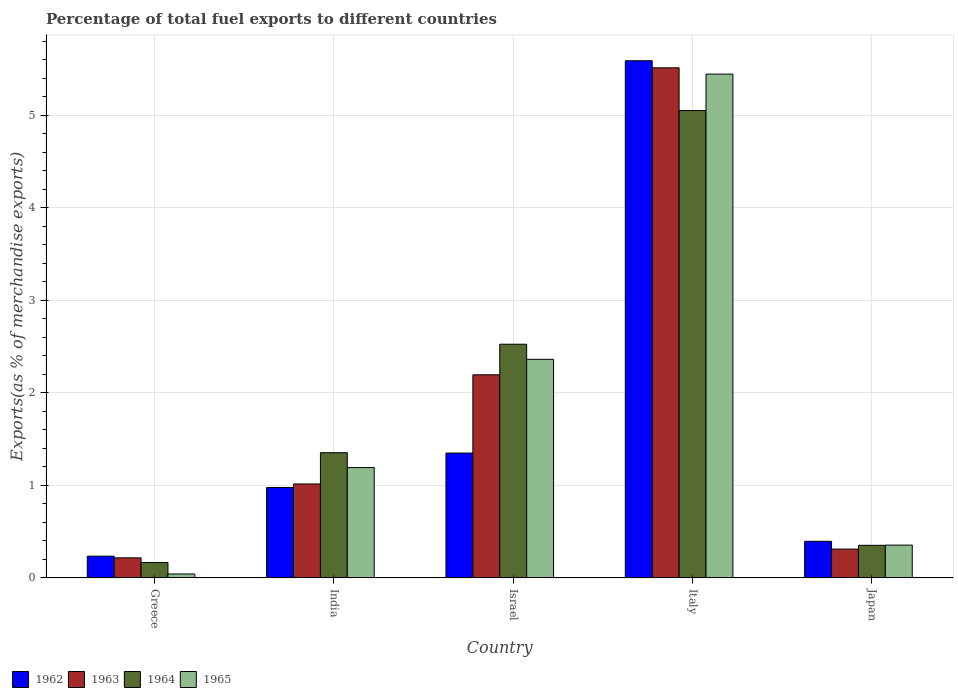How many different coloured bars are there?
Offer a very short reply. 4. How many groups of bars are there?
Give a very brief answer. 5. How many bars are there on the 4th tick from the left?
Offer a terse response. 4. How many bars are there on the 4th tick from the right?
Provide a succinct answer. 4. In how many cases, is the number of bars for a given country not equal to the number of legend labels?
Make the answer very short. 0. What is the percentage of exports to different countries in 1964 in India?
Your response must be concise. 1.35. Across all countries, what is the maximum percentage of exports to different countries in 1962?
Your response must be concise. 5.59. Across all countries, what is the minimum percentage of exports to different countries in 1964?
Provide a succinct answer. 0.17. In which country was the percentage of exports to different countries in 1963 minimum?
Offer a very short reply. Greece. What is the total percentage of exports to different countries in 1964 in the graph?
Provide a succinct answer. 9.45. What is the difference between the percentage of exports to different countries in 1962 in India and that in Israel?
Your answer should be very brief. -0.37. What is the difference between the percentage of exports to different countries in 1962 in Greece and the percentage of exports to different countries in 1964 in Italy?
Provide a succinct answer. -4.82. What is the average percentage of exports to different countries in 1963 per country?
Keep it short and to the point. 1.85. What is the difference between the percentage of exports to different countries of/in 1962 and percentage of exports to different countries of/in 1965 in India?
Offer a terse response. -0.22. In how many countries, is the percentage of exports to different countries in 1964 greater than 0.2 %?
Offer a terse response. 4. What is the ratio of the percentage of exports to different countries in 1962 in Greece to that in Italy?
Your answer should be very brief. 0.04. Is the percentage of exports to different countries in 1963 in India less than that in Japan?
Provide a short and direct response. No. Is the difference between the percentage of exports to different countries in 1962 in Greece and India greater than the difference between the percentage of exports to different countries in 1965 in Greece and India?
Provide a short and direct response. Yes. What is the difference between the highest and the second highest percentage of exports to different countries in 1962?
Offer a very short reply. -0.37. What is the difference between the highest and the lowest percentage of exports to different countries in 1964?
Give a very brief answer. 4.88. Is it the case that in every country, the sum of the percentage of exports to different countries in 1963 and percentage of exports to different countries in 1962 is greater than the sum of percentage of exports to different countries in 1964 and percentage of exports to different countries in 1965?
Ensure brevity in your answer.  No. What does the 4th bar from the left in Greece represents?
Offer a terse response. 1965. How many bars are there?
Provide a succinct answer. 20. Are the values on the major ticks of Y-axis written in scientific E-notation?
Provide a short and direct response. No. Does the graph contain any zero values?
Ensure brevity in your answer.  No. How many legend labels are there?
Your answer should be very brief. 4. What is the title of the graph?
Give a very brief answer. Percentage of total fuel exports to different countries. Does "1973" appear as one of the legend labels in the graph?
Offer a very short reply. No. What is the label or title of the Y-axis?
Provide a short and direct response. Exports(as % of merchandise exports). What is the Exports(as % of merchandise exports) of 1962 in Greece?
Your response must be concise. 0.24. What is the Exports(as % of merchandise exports) of 1963 in Greece?
Offer a terse response. 0.22. What is the Exports(as % of merchandise exports) of 1964 in Greece?
Provide a succinct answer. 0.17. What is the Exports(as % of merchandise exports) of 1965 in Greece?
Provide a succinct answer. 0.04. What is the Exports(as % of merchandise exports) in 1962 in India?
Ensure brevity in your answer.  0.98. What is the Exports(as % of merchandise exports) of 1963 in India?
Give a very brief answer. 1.02. What is the Exports(as % of merchandise exports) in 1964 in India?
Your answer should be compact. 1.35. What is the Exports(as % of merchandise exports) of 1965 in India?
Your answer should be very brief. 1.19. What is the Exports(as % of merchandise exports) of 1962 in Israel?
Keep it short and to the point. 1.35. What is the Exports(as % of merchandise exports) in 1963 in Israel?
Your response must be concise. 2.2. What is the Exports(as % of merchandise exports) of 1964 in Israel?
Make the answer very short. 2.53. What is the Exports(as % of merchandise exports) of 1965 in Israel?
Your answer should be compact. 2.36. What is the Exports(as % of merchandise exports) of 1962 in Italy?
Provide a succinct answer. 5.59. What is the Exports(as % of merchandise exports) of 1963 in Italy?
Your response must be concise. 5.51. What is the Exports(as % of merchandise exports) of 1964 in Italy?
Give a very brief answer. 5.05. What is the Exports(as % of merchandise exports) of 1965 in Italy?
Make the answer very short. 5.45. What is the Exports(as % of merchandise exports) in 1962 in Japan?
Your answer should be compact. 0.4. What is the Exports(as % of merchandise exports) in 1963 in Japan?
Keep it short and to the point. 0.31. What is the Exports(as % of merchandise exports) in 1964 in Japan?
Your response must be concise. 0.35. What is the Exports(as % of merchandise exports) of 1965 in Japan?
Make the answer very short. 0.36. Across all countries, what is the maximum Exports(as % of merchandise exports) of 1962?
Offer a very short reply. 5.59. Across all countries, what is the maximum Exports(as % of merchandise exports) of 1963?
Your response must be concise. 5.51. Across all countries, what is the maximum Exports(as % of merchandise exports) of 1964?
Your answer should be compact. 5.05. Across all countries, what is the maximum Exports(as % of merchandise exports) of 1965?
Offer a very short reply. 5.45. Across all countries, what is the minimum Exports(as % of merchandise exports) in 1962?
Provide a short and direct response. 0.24. Across all countries, what is the minimum Exports(as % of merchandise exports) in 1963?
Make the answer very short. 0.22. Across all countries, what is the minimum Exports(as % of merchandise exports) in 1964?
Ensure brevity in your answer.  0.17. Across all countries, what is the minimum Exports(as % of merchandise exports) in 1965?
Your response must be concise. 0.04. What is the total Exports(as % of merchandise exports) in 1962 in the graph?
Your answer should be compact. 8.55. What is the total Exports(as % of merchandise exports) in 1963 in the graph?
Offer a very short reply. 9.26. What is the total Exports(as % of merchandise exports) of 1964 in the graph?
Your response must be concise. 9.45. What is the total Exports(as % of merchandise exports) in 1965 in the graph?
Keep it short and to the point. 9.4. What is the difference between the Exports(as % of merchandise exports) in 1962 in Greece and that in India?
Make the answer very short. -0.74. What is the difference between the Exports(as % of merchandise exports) in 1963 in Greece and that in India?
Keep it short and to the point. -0.8. What is the difference between the Exports(as % of merchandise exports) in 1964 in Greece and that in India?
Provide a succinct answer. -1.19. What is the difference between the Exports(as % of merchandise exports) in 1965 in Greece and that in India?
Give a very brief answer. -1.15. What is the difference between the Exports(as % of merchandise exports) of 1962 in Greece and that in Israel?
Your answer should be compact. -1.11. What is the difference between the Exports(as % of merchandise exports) of 1963 in Greece and that in Israel?
Offer a very short reply. -1.98. What is the difference between the Exports(as % of merchandise exports) of 1964 in Greece and that in Israel?
Your response must be concise. -2.36. What is the difference between the Exports(as % of merchandise exports) in 1965 in Greece and that in Israel?
Ensure brevity in your answer.  -2.32. What is the difference between the Exports(as % of merchandise exports) of 1962 in Greece and that in Italy?
Offer a terse response. -5.35. What is the difference between the Exports(as % of merchandise exports) in 1963 in Greece and that in Italy?
Your answer should be very brief. -5.3. What is the difference between the Exports(as % of merchandise exports) of 1964 in Greece and that in Italy?
Your answer should be very brief. -4.88. What is the difference between the Exports(as % of merchandise exports) in 1965 in Greece and that in Italy?
Your response must be concise. -5.4. What is the difference between the Exports(as % of merchandise exports) in 1962 in Greece and that in Japan?
Offer a very short reply. -0.16. What is the difference between the Exports(as % of merchandise exports) in 1963 in Greece and that in Japan?
Ensure brevity in your answer.  -0.09. What is the difference between the Exports(as % of merchandise exports) in 1964 in Greece and that in Japan?
Ensure brevity in your answer.  -0.19. What is the difference between the Exports(as % of merchandise exports) in 1965 in Greece and that in Japan?
Your response must be concise. -0.31. What is the difference between the Exports(as % of merchandise exports) in 1962 in India and that in Israel?
Give a very brief answer. -0.37. What is the difference between the Exports(as % of merchandise exports) of 1963 in India and that in Israel?
Provide a succinct answer. -1.18. What is the difference between the Exports(as % of merchandise exports) of 1964 in India and that in Israel?
Your answer should be very brief. -1.17. What is the difference between the Exports(as % of merchandise exports) in 1965 in India and that in Israel?
Your answer should be compact. -1.17. What is the difference between the Exports(as % of merchandise exports) in 1962 in India and that in Italy?
Your answer should be very brief. -4.61. What is the difference between the Exports(as % of merchandise exports) in 1963 in India and that in Italy?
Give a very brief answer. -4.5. What is the difference between the Exports(as % of merchandise exports) in 1964 in India and that in Italy?
Your answer should be compact. -3.7. What is the difference between the Exports(as % of merchandise exports) of 1965 in India and that in Italy?
Your answer should be compact. -4.25. What is the difference between the Exports(as % of merchandise exports) in 1962 in India and that in Japan?
Offer a very short reply. 0.58. What is the difference between the Exports(as % of merchandise exports) of 1963 in India and that in Japan?
Ensure brevity in your answer.  0.7. What is the difference between the Exports(as % of merchandise exports) in 1964 in India and that in Japan?
Your answer should be compact. 1. What is the difference between the Exports(as % of merchandise exports) in 1965 in India and that in Japan?
Make the answer very short. 0.84. What is the difference between the Exports(as % of merchandise exports) in 1962 in Israel and that in Italy?
Give a very brief answer. -4.24. What is the difference between the Exports(as % of merchandise exports) of 1963 in Israel and that in Italy?
Offer a very short reply. -3.32. What is the difference between the Exports(as % of merchandise exports) of 1964 in Israel and that in Italy?
Offer a very short reply. -2.53. What is the difference between the Exports(as % of merchandise exports) in 1965 in Israel and that in Italy?
Give a very brief answer. -3.08. What is the difference between the Exports(as % of merchandise exports) in 1962 in Israel and that in Japan?
Provide a short and direct response. 0.95. What is the difference between the Exports(as % of merchandise exports) in 1963 in Israel and that in Japan?
Your answer should be compact. 1.88. What is the difference between the Exports(as % of merchandise exports) in 1964 in Israel and that in Japan?
Your answer should be very brief. 2.17. What is the difference between the Exports(as % of merchandise exports) in 1965 in Israel and that in Japan?
Offer a terse response. 2.01. What is the difference between the Exports(as % of merchandise exports) of 1962 in Italy and that in Japan?
Provide a succinct answer. 5.19. What is the difference between the Exports(as % of merchandise exports) in 1963 in Italy and that in Japan?
Offer a terse response. 5.2. What is the difference between the Exports(as % of merchandise exports) of 1964 in Italy and that in Japan?
Your answer should be very brief. 4.7. What is the difference between the Exports(as % of merchandise exports) of 1965 in Italy and that in Japan?
Ensure brevity in your answer.  5.09. What is the difference between the Exports(as % of merchandise exports) of 1962 in Greece and the Exports(as % of merchandise exports) of 1963 in India?
Your answer should be compact. -0.78. What is the difference between the Exports(as % of merchandise exports) in 1962 in Greece and the Exports(as % of merchandise exports) in 1964 in India?
Provide a short and direct response. -1.12. What is the difference between the Exports(as % of merchandise exports) in 1962 in Greece and the Exports(as % of merchandise exports) in 1965 in India?
Give a very brief answer. -0.96. What is the difference between the Exports(as % of merchandise exports) of 1963 in Greece and the Exports(as % of merchandise exports) of 1964 in India?
Offer a very short reply. -1.14. What is the difference between the Exports(as % of merchandise exports) of 1963 in Greece and the Exports(as % of merchandise exports) of 1965 in India?
Your answer should be compact. -0.98. What is the difference between the Exports(as % of merchandise exports) in 1964 in Greece and the Exports(as % of merchandise exports) in 1965 in India?
Your response must be concise. -1.03. What is the difference between the Exports(as % of merchandise exports) of 1962 in Greece and the Exports(as % of merchandise exports) of 1963 in Israel?
Offer a very short reply. -1.96. What is the difference between the Exports(as % of merchandise exports) in 1962 in Greece and the Exports(as % of merchandise exports) in 1964 in Israel?
Give a very brief answer. -2.29. What is the difference between the Exports(as % of merchandise exports) in 1962 in Greece and the Exports(as % of merchandise exports) in 1965 in Israel?
Provide a short and direct response. -2.13. What is the difference between the Exports(as % of merchandise exports) of 1963 in Greece and the Exports(as % of merchandise exports) of 1964 in Israel?
Your answer should be very brief. -2.31. What is the difference between the Exports(as % of merchandise exports) in 1963 in Greece and the Exports(as % of merchandise exports) in 1965 in Israel?
Your response must be concise. -2.15. What is the difference between the Exports(as % of merchandise exports) of 1964 in Greece and the Exports(as % of merchandise exports) of 1965 in Israel?
Ensure brevity in your answer.  -2.2. What is the difference between the Exports(as % of merchandise exports) in 1962 in Greece and the Exports(as % of merchandise exports) in 1963 in Italy?
Offer a terse response. -5.28. What is the difference between the Exports(as % of merchandise exports) in 1962 in Greece and the Exports(as % of merchandise exports) in 1964 in Italy?
Make the answer very short. -4.82. What is the difference between the Exports(as % of merchandise exports) in 1962 in Greece and the Exports(as % of merchandise exports) in 1965 in Italy?
Offer a terse response. -5.21. What is the difference between the Exports(as % of merchandise exports) in 1963 in Greece and the Exports(as % of merchandise exports) in 1964 in Italy?
Ensure brevity in your answer.  -4.83. What is the difference between the Exports(as % of merchandise exports) in 1963 in Greece and the Exports(as % of merchandise exports) in 1965 in Italy?
Keep it short and to the point. -5.23. What is the difference between the Exports(as % of merchandise exports) of 1964 in Greece and the Exports(as % of merchandise exports) of 1965 in Italy?
Provide a succinct answer. -5.28. What is the difference between the Exports(as % of merchandise exports) in 1962 in Greece and the Exports(as % of merchandise exports) in 1963 in Japan?
Give a very brief answer. -0.08. What is the difference between the Exports(as % of merchandise exports) of 1962 in Greece and the Exports(as % of merchandise exports) of 1964 in Japan?
Ensure brevity in your answer.  -0.12. What is the difference between the Exports(as % of merchandise exports) in 1962 in Greece and the Exports(as % of merchandise exports) in 1965 in Japan?
Offer a terse response. -0.12. What is the difference between the Exports(as % of merchandise exports) in 1963 in Greece and the Exports(as % of merchandise exports) in 1964 in Japan?
Ensure brevity in your answer.  -0.14. What is the difference between the Exports(as % of merchandise exports) in 1963 in Greece and the Exports(as % of merchandise exports) in 1965 in Japan?
Make the answer very short. -0.14. What is the difference between the Exports(as % of merchandise exports) of 1964 in Greece and the Exports(as % of merchandise exports) of 1965 in Japan?
Ensure brevity in your answer.  -0.19. What is the difference between the Exports(as % of merchandise exports) in 1962 in India and the Exports(as % of merchandise exports) in 1963 in Israel?
Your response must be concise. -1.22. What is the difference between the Exports(as % of merchandise exports) in 1962 in India and the Exports(as % of merchandise exports) in 1964 in Israel?
Offer a terse response. -1.55. What is the difference between the Exports(as % of merchandise exports) in 1962 in India and the Exports(as % of merchandise exports) in 1965 in Israel?
Offer a terse response. -1.38. What is the difference between the Exports(as % of merchandise exports) of 1963 in India and the Exports(as % of merchandise exports) of 1964 in Israel?
Keep it short and to the point. -1.51. What is the difference between the Exports(as % of merchandise exports) in 1963 in India and the Exports(as % of merchandise exports) in 1965 in Israel?
Your response must be concise. -1.35. What is the difference between the Exports(as % of merchandise exports) in 1964 in India and the Exports(as % of merchandise exports) in 1965 in Israel?
Your response must be concise. -1.01. What is the difference between the Exports(as % of merchandise exports) of 1962 in India and the Exports(as % of merchandise exports) of 1963 in Italy?
Give a very brief answer. -4.54. What is the difference between the Exports(as % of merchandise exports) in 1962 in India and the Exports(as % of merchandise exports) in 1964 in Italy?
Offer a terse response. -4.07. What is the difference between the Exports(as % of merchandise exports) in 1962 in India and the Exports(as % of merchandise exports) in 1965 in Italy?
Provide a succinct answer. -4.47. What is the difference between the Exports(as % of merchandise exports) in 1963 in India and the Exports(as % of merchandise exports) in 1964 in Italy?
Provide a short and direct response. -4.04. What is the difference between the Exports(as % of merchandise exports) of 1963 in India and the Exports(as % of merchandise exports) of 1965 in Italy?
Your answer should be compact. -4.43. What is the difference between the Exports(as % of merchandise exports) of 1964 in India and the Exports(as % of merchandise exports) of 1965 in Italy?
Offer a very short reply. -4.09. What is the difference between the Exports(as % of merchandise exports) of 1962 in India and the Exports(as % of merchandise exports) of 1963 in Japan?
Your answer should be very brief. 0.67. What is the difference between the Exports(as % of merchandise exports) in 1962 in India and the Exports(as % of merchandise exports) in 1964 in Japan?
Offer a terse response. 0.63. What is the difference between the Exports(as % of merchandise exports) of 1962 in India and the Exports(as % of merchandise exports) of 1965 in Japan?
Offer a terse response. 0.62. What is the difference between the Exports(as % of merchandise exports) in 1963 in India and the Exports(as % of merchandise exports) in 1964 in Japan?
Make the answer very short. 0.66. What is the difference between the Exports(as % of merchandise exports) in 1963 in India and the Exports(as % of merchandise exports) in 1965 in Japan?
Keep it short and to the point. 0.66. What is the difference between the Exports(as % of merchandise exports) in 1962 in Israel and the Exports(as % of merchandise exports) in 1963 in Italy?
Give a very brief answer. -4.16. What is the difference between the Exports(as % of merchandise exports) in 1962 in Israel and the Exports(as % of merchandise exports) in 1964 in Italy?
Keep it short and to the point. -3.7. What is the difference between the Exports(as % of merchandise exports) in 1962 in Israel and the Exports(as % of merchandise exports) in 1965 in Italy?
Your response must be concise. -4.09. What is the difference between the Exports(as % of merchandise exports) of 1963 in Israel and the Exports(as % of merchandise exports) of 1964 in Italy?
Keep it short and to the point. -2.86. What is the difference between the Exports(as % of merchandise exports) in 1963 in Israel and the Exports(as % of merchandise exports) in 1965 in Italy?
Your answer should be very brief. -3.25. What is the difference between the Exports(as % of merchandise exports) of 1964 in Israel and the Exports(as % of merchandise exports) of 1965 in Italy?
Your answer should be very brief. -2.92. What is the difference between the Exports(as % of merchandise exports) in 1962 in Israel and the Exports(as % of merchandise exports) in 1963 in Japan?
Offer a very short reply. 1.04. What is the difference between the Exports(as % of merchandise exports) of 1962 in Israel and the Exports(as % of merchandise exports) of 1964 in Japan?
Your answer should be very brief. 1. What is the difference between the Exports(as % of merchandise exports) in 1963 in Israel and the Exports(as % of merchandise exports) in 1964 in Japan?
Give a very brief answer. 1.84. What is the difference between the Exports(as % of merchandise exports) of 1963 in Israel and the Exports(as % of merchandise exports) of 1965 in Japan?
Ensure brevity in your answer.  1.84. What is the difference between the Exports(as % of merchandise exports) in 1964 in Israel and the Exports(as % of merchandise exports) in 1965 in Japan?
Ensure brevity in your answer.  2.17. What is the difference between the Exports(as % of merchandise exports) of 1962 in Italy and the Exports(as % of merchandise exports) of 1963 in Japan?
Your response must be concise. 5.28. What is the difference between the Exports(as % of merchandise exports) of 1962 in Italy and the Exports(as % of merchandise exports) of 1964 in Japan?
Provide a short and direct response. 5.24. What is the difference between the Exports(as % of merchandise exports) of 1962 in Italy and the Exports(as % of merchandise exports) of 1965 in Japan?
Offer a very short reply. 5.23. What is the difference between the Exports(as % of merchandise exports) of 1963 in Italy and the Exports(as % of merchandise exports) of 1964 in Japan?
Your answer should be compact. 5.16. What is the difference between the Exports(as % of merchandise exports) of 1963 in Italy and the Exports(as % of merchandise exports) of 1965 in Japan?
Make the answer very short. 5.16. What is the difference between the Exports(as % of merchandise exports) in 1964 in Italy and the Exports(as % of merchandise exports) in 1965 in Japan?
Offer a terse response. 4.7. What is the average Exports(as % of merchandise exports) in 1962 per country?
Your answer should be compact. 1.71. What is the average Exports(as % of merchandise exports) in 1963 per country?
Give a very brief answer. 1.85. What is the average Exports(as % of merchandise exports) of 1964 per country?
Your answer should be very brief. 1.89. What is the average Exports(as % of merchandise exports) of 1965 per country?
Offer a very short reply. 1.88. What is the difference between the Exports(as % of merchandise exports) in 1962 and Exports(as % of merchandise exports) in 1963 in Greece?
Offer a terse response. 0.02. What is the difference between the Exports(as % of merchandise exports) of 1962 and Exports(as % of merchandise exports) of 1964 in Greece?
Give a very brief answer. 0.07. What is the difference between the Exports(as % of merchandise exports) of 1962 and Exports(as % of merchandise exports) of 1965 in Greece?
Make the answer very short. 0.19. What is the difference between the Exports(as % of merchandise exports) in 1963 and Exports(as % of merchandise exports) in 1964 in Greece?
Give a very brief answer. 0.05. What is the difference between the Exports(as % of merchandise exports) in 1963 and Exports(as % of merchandise exports) in 1965 in Greece?
Your answer should be very brief. 0.17. What is the difference between the Exports(as % of merchandise exports) in 1964 and Exports(as % of merchandise exports) in 1965 in Greece?
Offer a very short reply. 0.12. What is the difference between the Exports(as % of merchandise exports) of 1962 and Exports(as % of merchandise exports) of 1963 in India?
Your answer should be very brief. -0.04. What is the difference between the Exports(as % of merchandise exports) in 1962 and Exports(as % of merchandise exports) in 1964 in India?
Your answer should be compact. -0.38. What is the difference between the Exports(as % of merchandise exports) in 1962 and Exports(as % of merchandise exports) in 1965 in India?
Your answer should be compact. -0.22. What is the difference between the Exports(as % of merchandise exports) of 1963 and Exports(as % of merchandise exports) of 1964 in India?
Give a very brief answer. -0.34. What is the difference between the Exports(as % of merchandise exports) in 1963 and Exports(as % of merchandise exports) in 1965 in India?
Give a very brief answer. -0.18. What is the difference between the Exports(as % of merchandise exports) in 1964 and Exports(as % of merchandise exports) in 1965 in India?
Provide a succinct answer. 0.16. What is the difference between the Exports(as % of merchandise exports) of 1962 and Exports(as % of merchandise exports) of 1963 in Israel?
Provide a short and direct response. -0.85. What is the difference between the Exports(as % of merchandise exports) in 1962 and Exports(as % of merchandise exports) in 1964 in Israel?
Your answer should be compact. -1.18. What is the difference between the Exports(as % of merchandise exports) in 1962 and Exports(as % of merchandise exports) in 1965 in Israel?
Give a very brief answer. -1.01. What is the difference between the Exports(as % of merchandise exports) in 1963 and Exports(as % of merchandise exports) in 1964 in Israel?
Offer a very short reply. -0.33. What is the difference between the Exports(as % of merchandise exports) in 1963 and Exports(as % of merchandise exports) in 1965 in Israel?
Give a very brief answer. -0.17. What is the difference between the Exports(as % of merchandise exports) of 1964 and Exports(as % of merchandise exports) of 1965 in Israel?
Offer a very short reply. 0.16. What is the difference between the Exports(as % of merchandise exports) of 1962 and Exports(as % of merchandise exports) of 1963 in Italy?
Your answer should be very brief. 0.08. What is the difference between the Exports(as % of merchandise exports) of 1962 and Exports(as % of merchandise exports) of 1964 in Italy?
Your answer should be compact. 0.54. What is the difference between the Exports(as % of merchandise exports) in 1962 and Exports(as % of merchandise exports) in 1965 in Italy?
Make the answer very short. 0.14. What is the difference between the Exports(as % of merchandise exports) in 1963 and Exports(as % of merchandise exports) in 1964 in Italy?
Offer a terse response. 0.46. What is the difference between the Exports(as % of merchandise exports) in 1963 and Exports(as % of merchandise exports) in 1965 in Italy?
Give a very brief answer. 0.07. What is the difference between the Exports(as % of merchandise exports) of 1964 and Exports(as % of merchandise exports) of 1965 in Italy?
Offer a terse response. -0.39. What is the difference between the Exports(as % of merchandise exports) of 1962 and Exports(as % of merchandise exports) of 1963 in Japan?
Ensure brevity in your answer.  0.08. What is the difference between the Exports(as % of merchandise exports) of 1962 and Exports(as % of merchandise exports) of 1964 in Japan?
Provide a succinct answer. 0.04. What is the difference between the Exports(as % of merchandise exports) of 1962 and Exports(as % of merchandise exports) of 1965 in Japan?
Give a very brief answer. 0.04. What is the difference between the Exports(as % of merchandise exports) of 1963 and Exports(as % of merchandise exports) of 1964 in Japan?
Your response must be concise. -0.04. What is the difference between the Exports(as % of merchandise exports) in 1963 and Exports(as % of merchandise exports) in 1965 in Japan?
Give a very brief answer. -0.04. What is the difference between the Exports(as % of merchandise exports) in 1964 and Exports(as % of merchandise exports) in 1965 in Japan?
Your response must be concise. -0. What is the ratio of the Exports(as % of merchandise exports) of 1962 in Greece to that in India?
Keep it short and to the point. 0.24. What is the ratio of the Exports(as % of merchandise exports) of 1963 in Greece to that in India?
Give a very brief answer. 0.21. What is the ratio of the Exports(as % of merchandise exports) in 1964 in Greece to that in India?
Make the answer very short. 0.12. What is the ratio of the Exports(as % of merchandise exports) in 1965 in Greece to that in India?
Provide a succinct answer. 0.04. What is the ratio of the Exports(as % of merchandise exports) in 1962 in Greece to that in Israel?
Give a very brief answer. 0.17. What is the ratio of the Exports(as % of merchandise exports) in 1963 in Greece to that in Israel?
Offer a very short reply. 0.1. What is the ratio of the Exports(as % of merchandise exports) in 1964 in Greece to that in Israel?
Keep it short and to the point. 0.07. What is the ratio of the Exports(as % of merchandise exports) of 1965 in Greece to that in Israel?
Your answer should be compact. 0.02. What is the ratio of the Exports(as % of merchandise exports) in 1962 in Greece to that in Italy?
Your answer should be very brief. 0.04. What is the ratio of the Exports(as % of merchandise exports) of 1963 in Greece to that in Italy?
Give a very brief answer. 0.04. What is the ratio of the Exports(as % of merchandise exports) in 1964 in Greece to that in Italy?
Ensure brevity in your answer.  0.03. What is the ratio of the Exports(as % of merchandise exports) in 1965 in Greece to that in Italy?
Provide a short and direct response. 0.01. What is the ratio of the Exports(as % of merchandise exports) in 1962 in Greece to that in Japan?
Keep it short and to the point. 0.59. What is the ratio of the Exports(as % of merchandise exports) in 1963 in Greece to that in Japan?
Offer a very short reply. 0.7. What is the ratio of the Exports(as % of merchandise exports) of 1964 in Greece to that in Japan?
Provide a succinct answer. 0.47. What is the ratio of the Exports(as % of merchandise exports) in 1965 in Greece to that in Japan?
Provide a succinct answer. 0.12. What is the ratio of the Exports(as % of merchandise exports) of 1962 in India to that in Israel?
Your answer should be very brief. 0.72. What is the ratio of the Exports(as % of merchandise exports) in 1963 in India to that in Israel?
Provide a succinct answer. 0.46. What is the ratio of the Exports(as % of merchandise exports) of 1964 in India to that in Israel?
Offer a terse response. 0.54. What is the ratio of the Exports(as % of merchandise exports) in 1965 in India to that in Israel?
Provide a succinct answer. 0.51. What is the ratio of the Exports(as % of merchandise exports) in 1962 in India to that in Italy?
Your response must be concise. 0.17. What is the ratio of the Exports(as % of merchandise exports) of 1963 in India to that in Italy?
Offer a very short reply. 0.18. What is the ratio of the Exports(as % of merchandise exports) of 1964 in India to that in Italy?
Your answer should be compact. 0.27. What is the ratio of the Exports(as % of merchandise exports) in 1965 in India to that in Italy?
Make the answer very short. 0.22. What is the ratio of the Exports(as % of merchandise exports) of 1962 in India to that in Japan?
Give a very brief answer. 2.47. What is the ratio of the Exports(as % of merchandise exports) in 1963 in India to that in Japan?
Your answer should be compact. 3.25. What is the ratio of the Exports(as % of merchandise exports) in 1964 in India to that in Japan?
Give a very brief answer. 3.83. What is the ratio of the Exports(as % of merchandise exports) in 1965 in India to that in Japan?
Give a very brief answer. 3.36. What is the ratio of the Exports(as % of merchandise exports) of 1962 in Israel to that in Italy?
Your answer should be compact. 0.24. What is the ratio of the Exports(as % of merchandise exports) in 1963 in Israel to that in Italy?
Your answer should be compact. 0.4. What is the ratio of the Exports(as % of merchandise exports) in 1964 in Israel to that in Italy?
Provide a short and direct response. 0.5. What is the ratio of the Exports(as % of merchandise exports) of 1965 in Israel to that in Italy?
Your response must be concise. 0.43. What is the ratio of the Exports(as % of merchandise exports) of 1962 in Israel to that in Japan?
Give a very brief answer. 3.4. What is the ratio of the Exports(as % of merchandise exports) of 1963 in Israel to that in Japan?
Offer a very short reply. 7.03. What is the ratio of the Exports(as % of merchandise exports) in 1964 in Israel to that in Japan?
Provide a succinct answer. 7.16. What is the ratio of the Exports(as % of merchandise exports) in 1965 in Israel to that in Japan?
Your answer should be very brief. 6.65. What is the ratio of the Exports(as % of merchandise exports) in 1962 in Italy to that in Japan?
Your response must be concise. 14.1. What is the ratio of the Exports(as % of merchandise exports) in 1963 in Italy to that in Japan?
Provide a short and direct response. 17.64. What is the ratio of the Exports(as % of merchandise exports) of 1964 in Italy to that in Japan?
Keep it short and to the point. 14.31. What is the ratio of the Exports(as % of merchandise exports) in 1965 in Italy to that in Japan?
Ensure brevity in your answer.  15.32. What is the difference between the highest and the second highest Exports(as % of merchandise exports) of 1962?
Your answer should be compact. 4.24. What is the difference between the highest and the second highest Exports(as % of merchandise exports) in 1963?
Offer a very short reply. 3.32. What is the difference between the highest and the second highest Exports(as % of merchandise exports) of 1964?
Keep it short and to the point. 2.53. What is the difference between the highest and the second highest Exports(as % of merchandise exports) in 1965?
Make the answer very short. 3.08. What is the difference between the highest and the lowest Exports(as % of merchandise exports) in 1962?
Offer a terse response. 5.35. What is the difference between the highest and the lowest Exports(as % of merchandise exports) in 1963?
Your response must be concise. 5.3. What is the difference between the highest and the lowest Exports(as % of merchandise exports) in 1964?
Your response must be concise. 4.88. What is the difference between the highest and the lowest Exports(as % of merchandise exports) of 1965?
Keep it short and to the point. 5.4. 